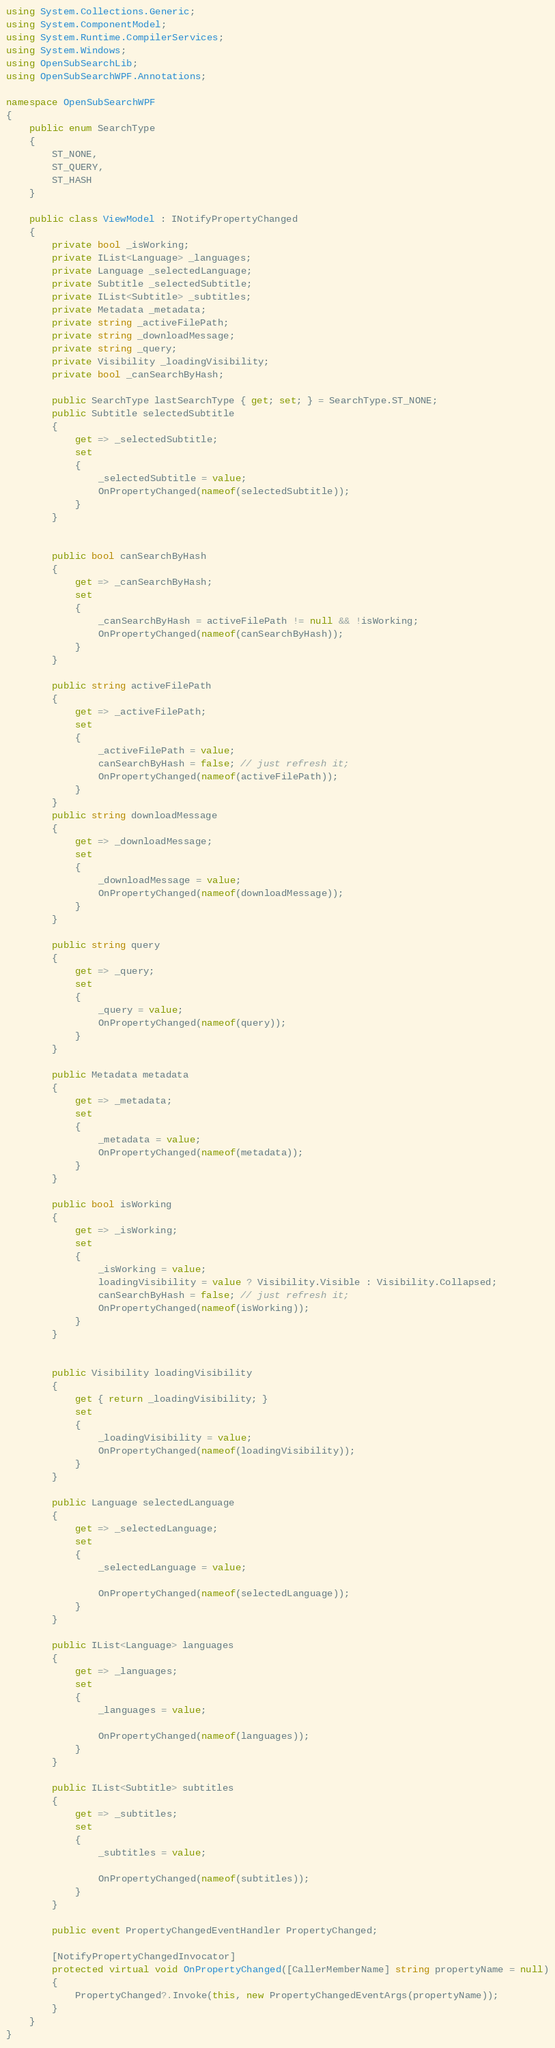<code> <loc_0><loc_0><loc_500><loc_500><_C#_>using System.Collections.Generic;
using System.ComponentModel;
using System.Runtime.CompilerServices;
using System.Windows;
using OpenSubSearchLib;
using OpenSubSearchWPF.Annotations;

namespace OpenSubSearchWPF
{
    public enum SearchType
    {
        ST_NONE,
        ST_QUERY,
        ST_HASH
    }

    public class ViewModel : INotifyPropertyChanged
    {
        private bool _isWorking;
        private IList<Language> _languages;
        private Language _selectedLanguage;
        private Subtitle _selectedSubtitle;
        private IList<Subtitle> _subtitles;
        private Metadata _metadata;
        private string _activeFilePath;
        private string _downloadMessage;
        private string _query;
        private Visibility _loadingVisibility;
        private bool _canSearchByHash;

        public SearchType lastSearchType { get; set; } = SearchType.ST_NONE;
        public Subtitle selectedSubtitle
        {
            get => _selectedSubtitle;
            set
            {
                _selectedSubtitle = value;
                OnPropertyChanged(nameof(selectedSubtitle));
            }
        }


        public bool canSearchByHash
        {
            get => _canSearchByHash;
            set
            {
                _canSearchByHash = activeFilePath != null && !isWorking;
                OnPropertyChanged(nameof(canSearchByHash));
            }
        }

        public string activeFilePath
        {
            get => _activeFilePath;
            set
            {
                _activeFilePath = value;
                canSearchByHash = false; // just refresh it;
                OnPropertyChanged(nameof(activeFilePath));
            }
        }
        public string downloadMessage
        {
            get => _downloadMessage;
            set
            {
                _downloadMessage = value;
                OnPropertyChanged(nameof(downloadMessage));
            }
        }

        public string query
        {
            get => _query;
            set
            {
                _query = value;
                OnPropertyChanged(nameof(query));
            }
        }

        public Metadata metadata
        {
            get => _metadata;
            set
            {
                _metadata = value;
                OnPropertyChanged(nameof(metadata));
            }
        }

        public bool isWorking
        {
            get => _isWorking;
            set
            {
                _isWorking = value;
                loadingVisibility = value ? Visibility.Visible : Visibility.Collapsed;
                canSearchByHash = false; // just refresh it;
                OnPropertyChanged(nameof(isWorking));
            }
        }


        public Visibility loadingVisibility
        {
            get { return _loadingVisibility; }
            set
            {
                _loadingVisibility = value;
                OnPropertyChanged(nameof(loadingVisibility));
            }
        }

        public Language selectedLanguage
        {
            get => _selectedLanguage;
            set
            {
                _selectedLanguage = value;

                OnPropertyChanged(nameof(selectedLanguage));
            }
        }

        public IList<Language> languages
        {
            get => _languages;
            set
            {
                _languages = value;

                OnPropertyChanged(nameof(languages));
            }
        }

        public IList<Subtitle> subtitles
        {
            get => _subtitles;
            set
            {
                _subtitles = value;

                OnPropertyChanged(nameof(subtitles));
            }
        }

        public event PropertyChangedEventHandler PropertyChanged;

        [NotifyPropertyChangedInvocator]
        protected virtual void OnPropertyChanged([CallerMemberName] string propertyName = null)
        {
            PropertyChanged?.Invoke(this, new PropertyChangedEventArgs(propertyName));
        }
    }
}</code> 